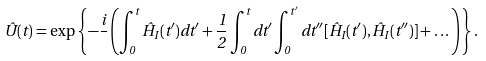Convert formula to latex. <formula><loc_0><loc_0><loc_500><loc_500>\hat { U } ( t ) = \exp \left \{ - \frac { i } { } \left ( \int _ { 0 } ^ { t } \hat { H } _ { I } ( t ^ { \prime } ) d t ^ { \prime } + \frac { 1 } { 2 } \int _ { 0 } ^ { t } d t ^ { \prime } \int _ { 0 } ^ { t ^ { \prime } } d t ^ { \prime \prime } [ \hat { H } _ { I } ( t ^ { \prime } ) , \hat { H } _ { I } ( t ^ { \prime \prime } ) ] + \dots \right ) \right \} .</formula> 